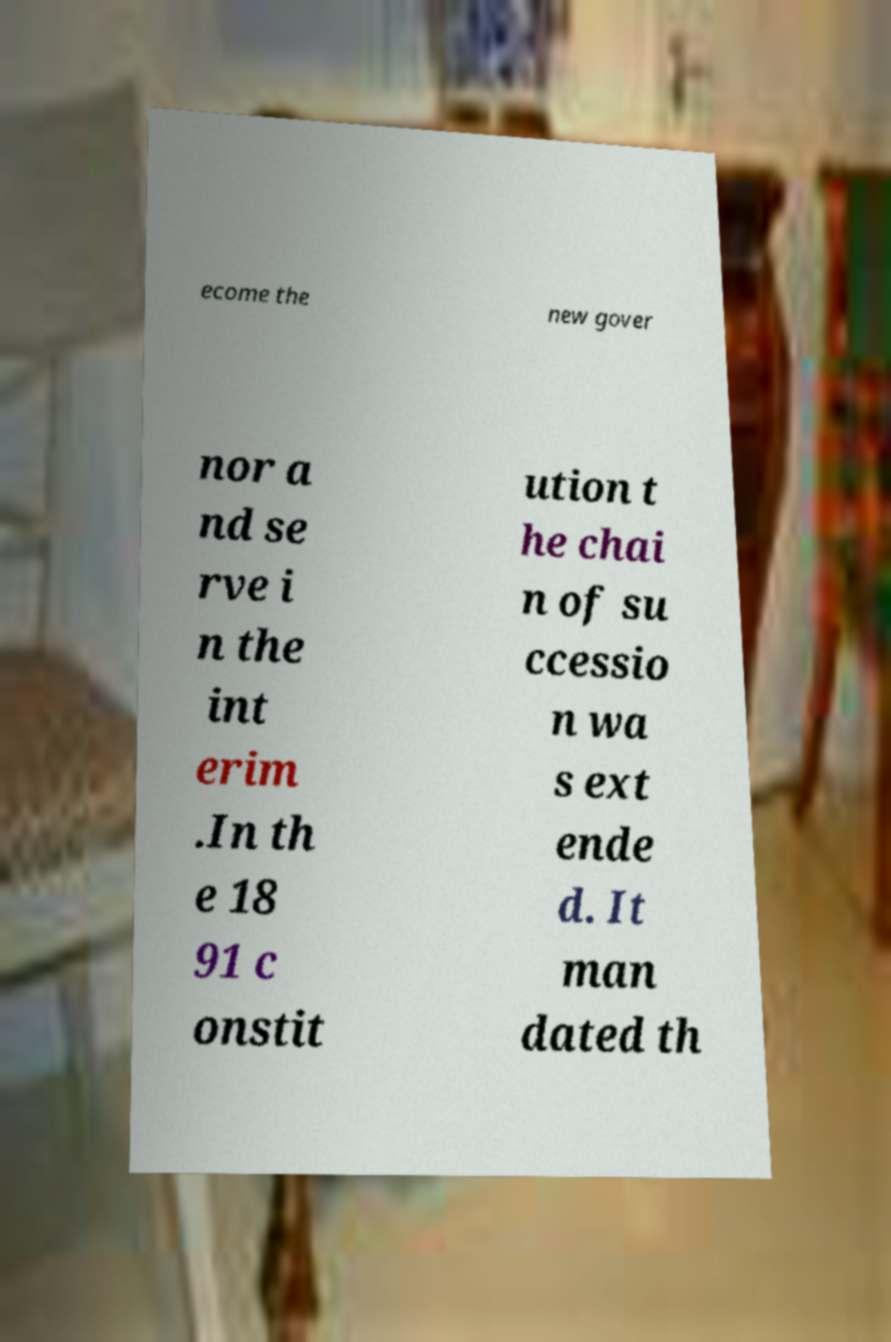I need the written content from this picture converted into text. Can you do that? ecome the new gover nor a nd se rve i n the int erim .In th e 18 91 c onstit ution t he chai n of su ccessio n wa s ext ende d. It man dated th 